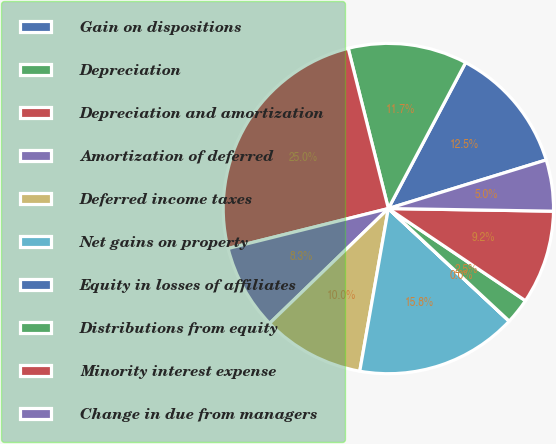Convert chart to OTSL. <chart><loc_0><loc_0><loc_500><loc_500><pie_chart><fcel>Gain on dispositions<fcel>Depreciation<fcel>Depreciation and amortization<fcel>Amortization of deferred<fcel>Deferred income taxes<fcel>Net gains on property<fcel>Equity in losses of affiliates<fcel>Distributions from equity<fcel>Minority interest expense<fcel>Change in due from managers<nl><fcel>12.5%<fcel>11.66%<fcel>24.98%<fcel>8.34%<fcel>10.0%<fcel>15.83%<fcel>0.01%<fcel>2.51%<fcel>9.17%<fcel>5.01%<nl></chart> 